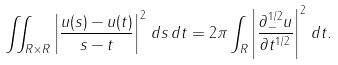Convert formula to latex. <formula><loc_0><loc_0><loc_500><loc_500>\iint _ { { R } \times { R } } \left | \frac { u ( s ) - u ( t ) } { s - t } \right | ^ { 2 } \, d s \, d t = 2 \pi \int _ { R } \left | \frac { \partial _ { - } ^ { 1 / 2 } u } { \partial t ^ { 1 / 2 } } \right | ^ { 2 } \, d t .</formula> 